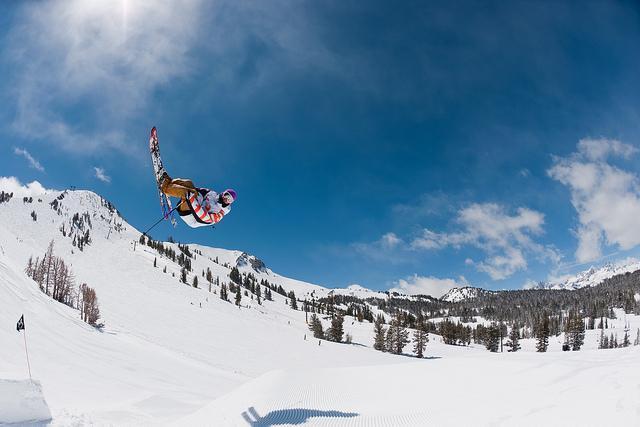How many cars in this picture?
Give a very brief answer. 0. 